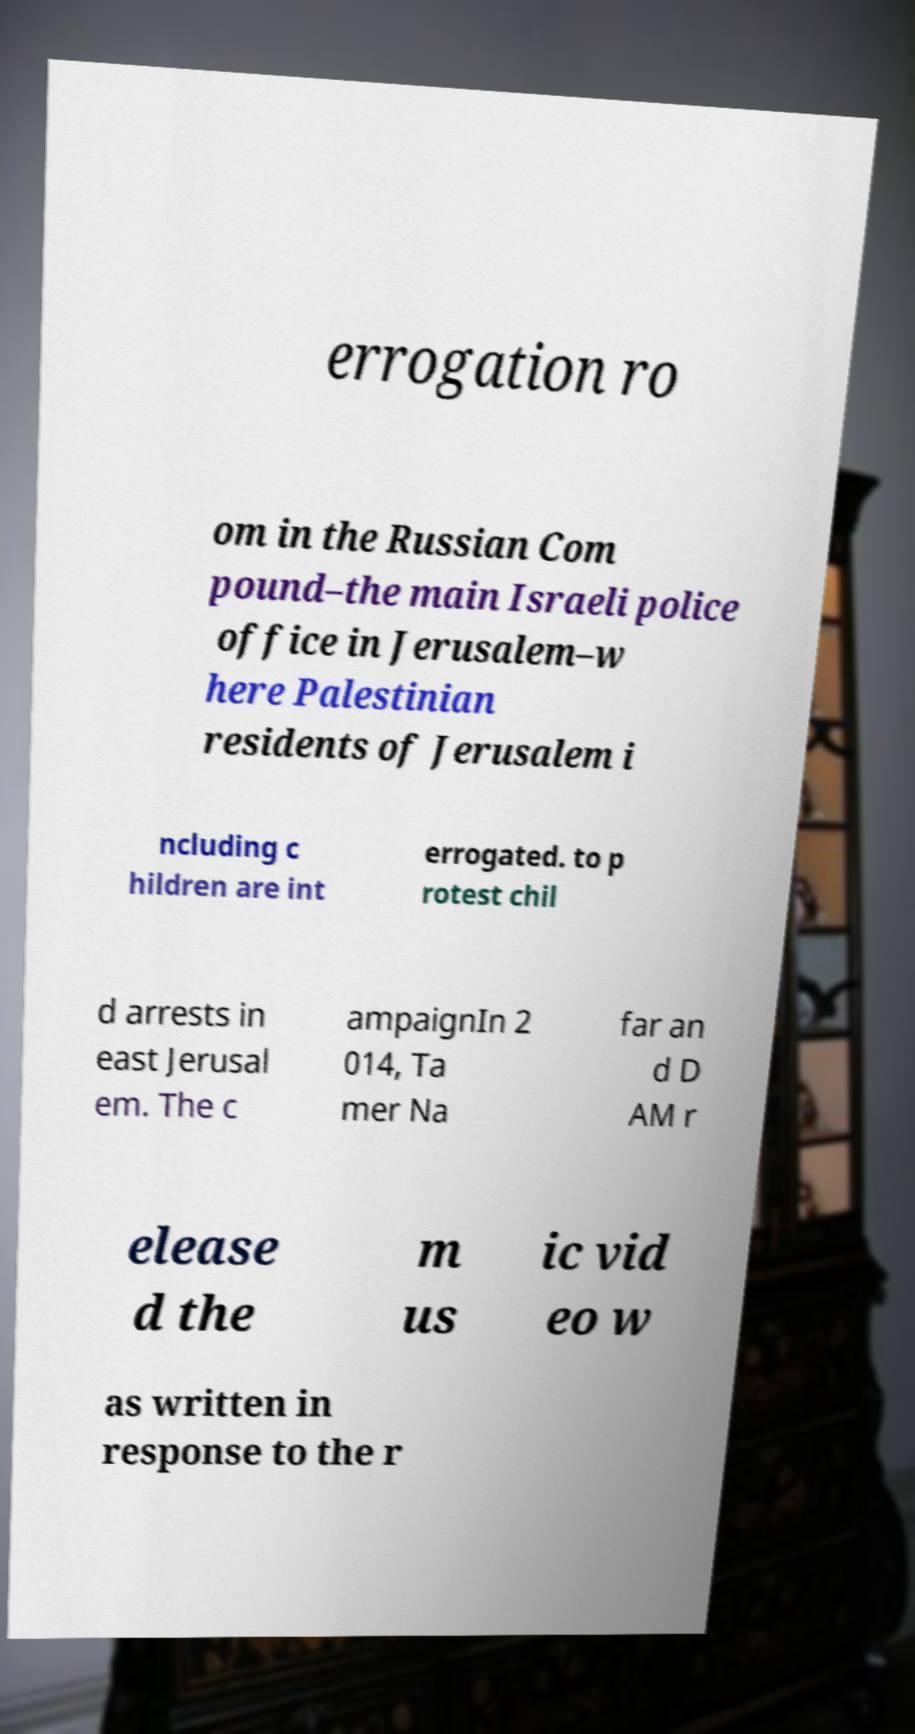What messages or text are displayed in this image? I need them in a readable, typed format. errogation ro om in the Russian Com pound–the main Israeli police office in Jerusalem–w here Palestinian residents of Jerusalem i ncluding c hildren are int errogated. to p rotest chil d arrests in east Jerusal em. The c ampaignIn 2 014, Ta mer Na far an d D AM r elease d the m us ic vid eo w as written in response to the r 